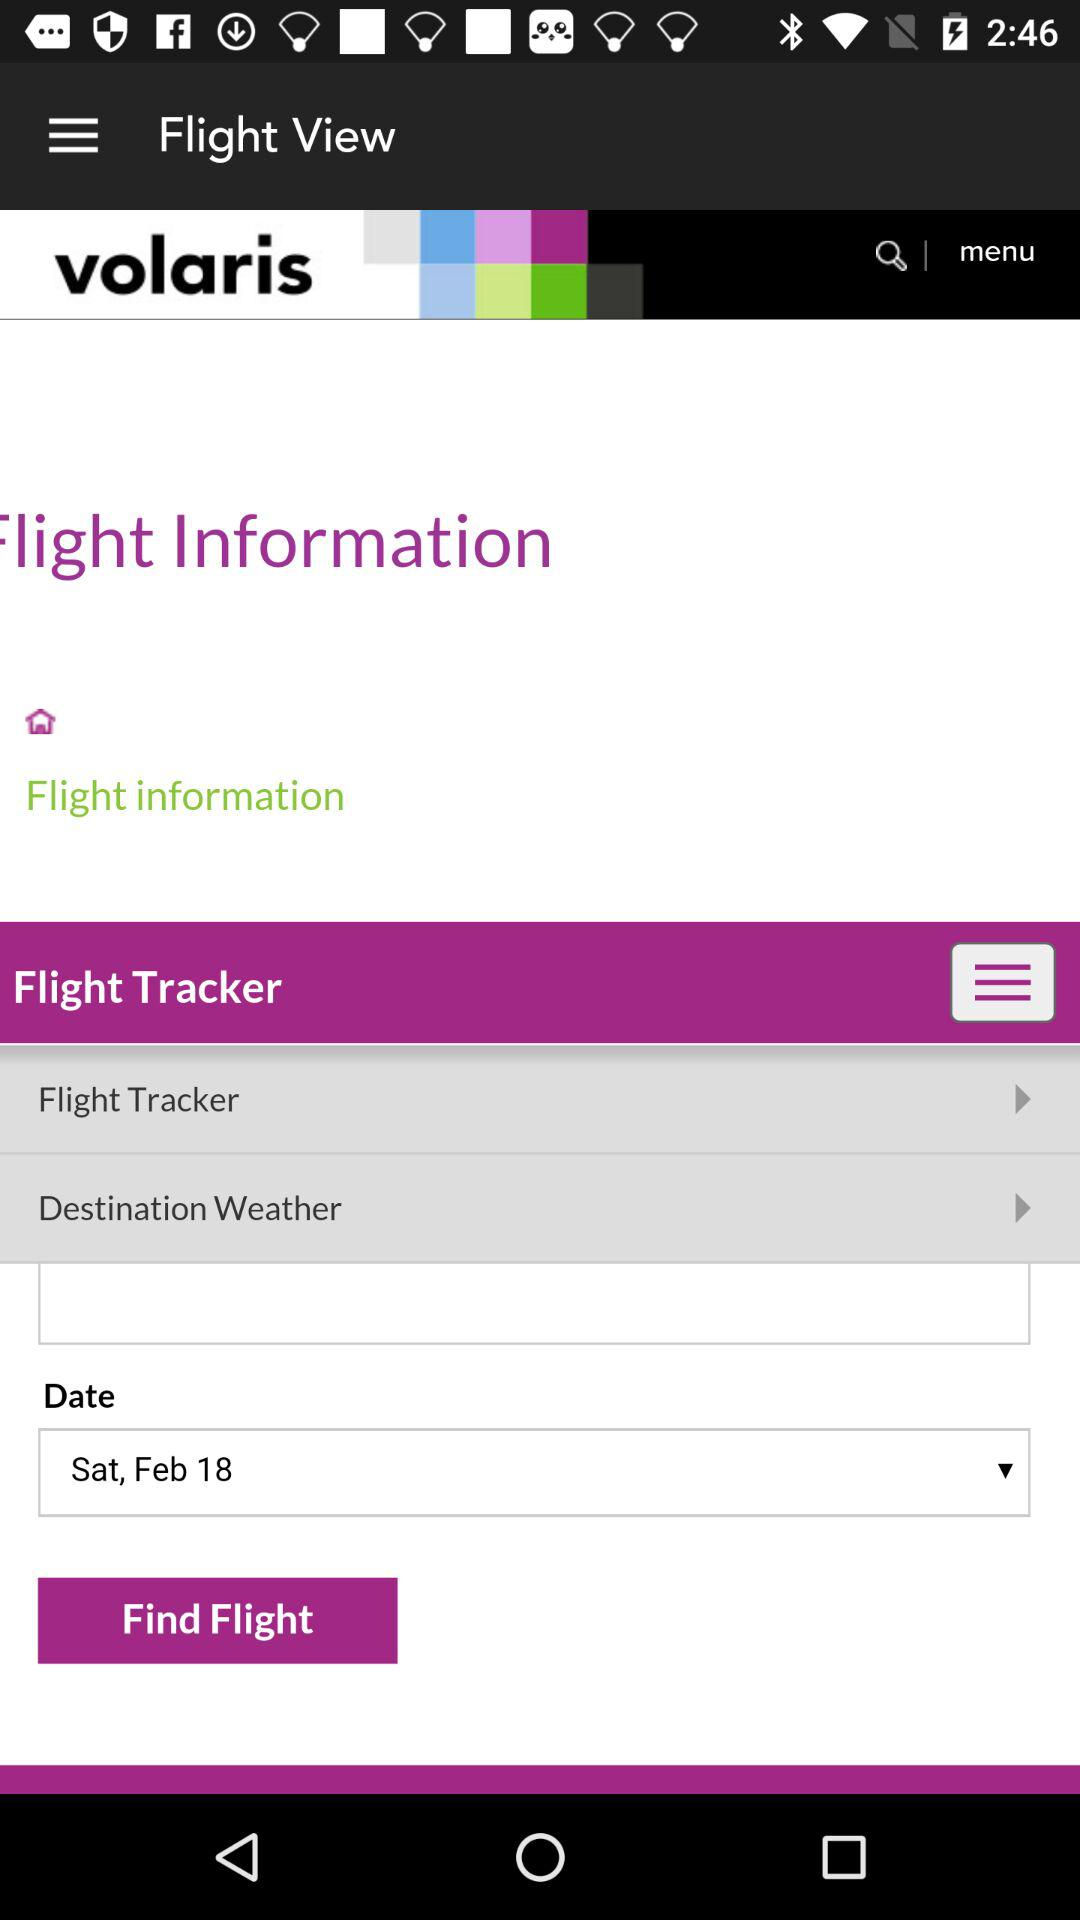What is the given date to search for a flight? The given date is Saturday, February 18. 